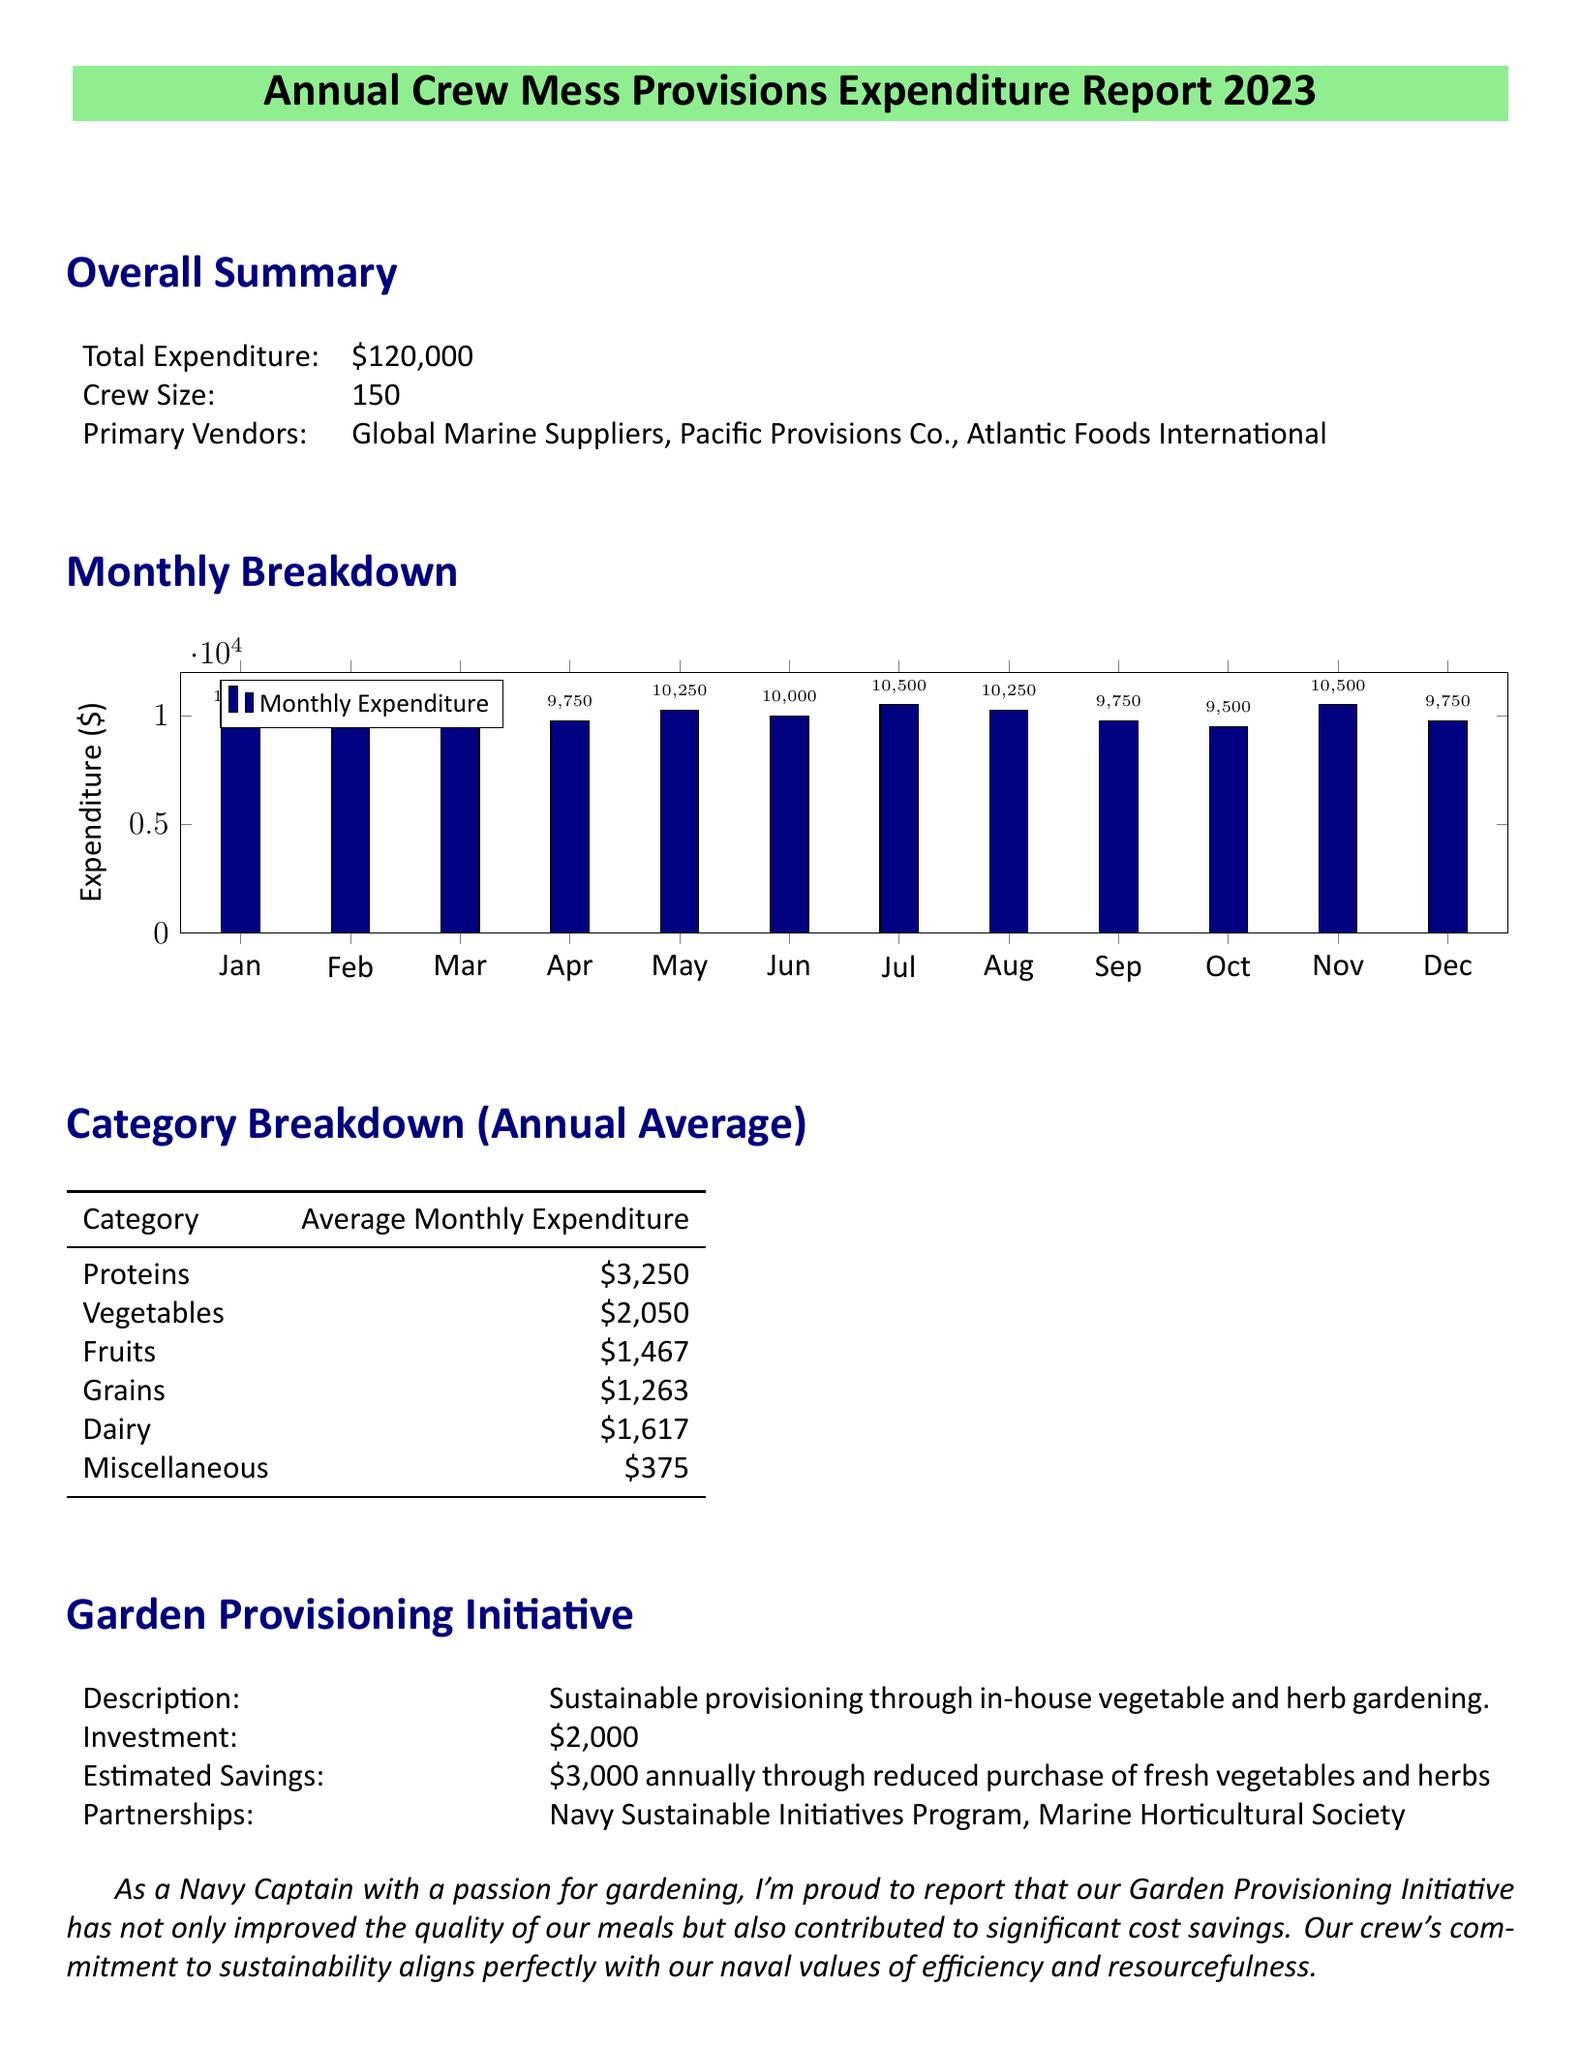What is the total expenditure? The total expenditure reported in the document is \$120,000.
Answer: \$120,000 How many crew members are there? The crew size stated in the document is 150 members.
Answer: 150 Which vendor has the name "Pacific" in it? The document lists three primary vendors, one of which is Pacific Provisions Co.
Answer: Pacific Provisions Co What was the expenditure in July? The monthly expenditure breakdown indicates that in July, the expenditure was \$10,500.
Answer: \$10,500 What is the average monthly expenditure for proteins? The category breakdown shows that the average monthly expenditure for proteins is \$3,250.
Answer: \$3,250 What is the estimated annual savings from the Garden Provisioning Initiative? The document states that the estimated savings from the initiative is \$3,000 annually.
Answer: \$3,000 What was the investment cost for the Garden Provisioning Initiative? According to the report, the investment in the garden provisioning initiative was \$2,000.
Answer: \$2,000 What is the average monthly expenditure for miscellaneous items? The category breakdown indicates that the average monthly expenditure for miscellaneous items is \$375.
Answer: \$375 Which initiative contributes to cost savings? The initiative mentioned in the document that contributes to cost savings is the Garden Provisioning Initiative.
Answer: Garden Provisioning Initiative 